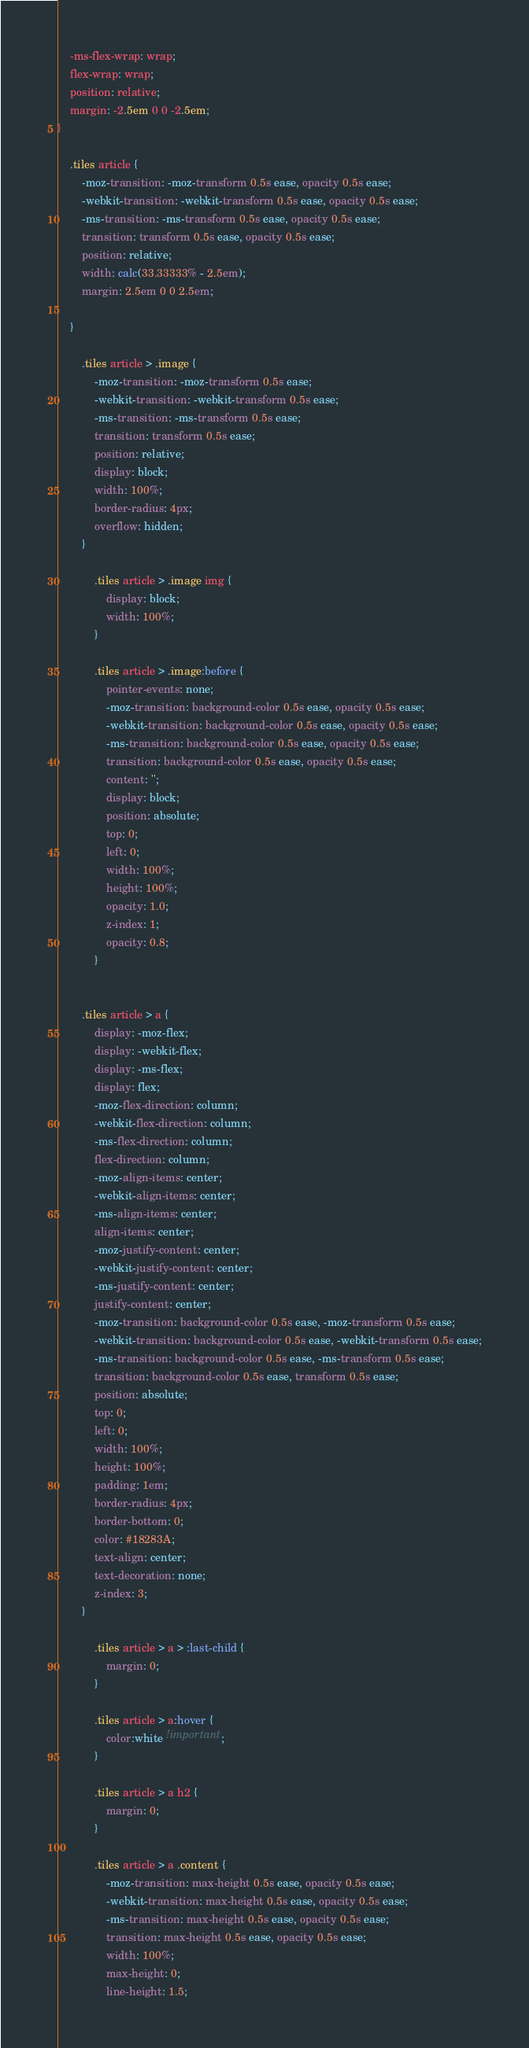Convert code to text. <code><loc_0><loc_0><loc_500><loc_500><_CSS_>	-ms-flex-wrap: wrap;
	flex-wrap: wrap;
	position: relative;
	margin: -2.5em 0 0 -2.5em;
}

	.tiles article {
		-moz-transition: -moz-transform 0.5s ease, opacity 0.5s ease;
		-webkit-transition: -webkit-transform 0.5s ease, opacity 0.5s ease;
		-ms-transition: -ms-transform 0.5s ease, opacity 0.5s ease;
		transition: transform 0.5s ease, opacity 0.5s ease;
		position: relative;
		width: calc(33.33333% - 2.5em);
		margin: 2.5em 0 0 2.5em;
		
	}

		.tiles article > .image {
			-moz-transition: -moz-transform 0.5s ease;
			-webkit-transition: -webkit-transform 0.5s ease;
			-ms-transition: -ms-transform 0.5s ease;
			transition: transform 0.5s ease;
			position: relative;
			display: block;
			width: 100%;
			border-radius: 4px;
			overflow: hidden;
		}

			.tiles article > .image img {
				display: block;
				width: 100%;
			}

			.tiles article > .image:before {
				pointer-events: none;
				-moz-transition: background-color 0.5s ease, opacity 0.5s ease;
				-webkit-transition: background-color 0.5s ease, opacity 0.5s ease;
				-ms-transition: background-color 0.5s ease, opacity 0.5s ease;
				transition: background-color 0.5s ease, opacity 0.5s ease;
				content: '';
				display: block;
				position: absolute;
				top: 0;
				left: 0;
				width: 100%;
				height: 100%;
				opacity: 1.0;
				z-index: 1;
				opacity: 0.8;
			}

			
		.tiles article > a {
			display: -moz-flex;
			display: -webkit-flex;
			display: -ms-flex;
			display: flex;
			-moz-flex-direction: column;
			-webkit-flex-direction: column;
			-ms-flex-direction: column;
			flex-direction: column;
			-moz-align-items: center;
			-webkit-align-items: center;
			-ms-align-items: center;
			align-items: center;
			-moz-justify-content: center;
			-webkit-justify-content: center;
			-ms-justify-content: center;
			justify-content: center;
			-moz-transition: background-color 0.5s ease, -moz-transform 0.5s ease;
			-webkit-transition: background-color 0.5s ease, -webkit-transform 0.5s ease;
			-ms-transition: background-color 0.5s ease, -ms-transform 0.5s ease;
			transition: background-color 0.5s ease, transform 0.5s ease;
			position: absolute;
			top: 0;
			left: 0;
			width: 100%;
			height: 100%;
			padding: 1em;
			border-radius: 4px;
			border-bottom: 0;
			color: #18283A;
			text-align: center;
			text-decoration: none;
			z-index: 3;
		}

			.tiles article > a > :last-child {
				margin: 0;
			}

			.tiles article > a:hover {
				color:white !important;
			}

			.tiles article > a h2 {
				margin: 0;
			}

			.tiles article > a .content {
				-moz-transition: max-height 0.5s ease, opacity 0.5s ease;
				-webkit-transition: max-height 0.5s ease, opacity 0.5s ease;
				-ms-transition: max-height 0.5s ease, opacity 0.5s ease;
				transition: max-height 0.5s ease, opacity 0.5s ease;
				width: 100%;
				max-height: 0;
				line-height: 1.5;</code> 